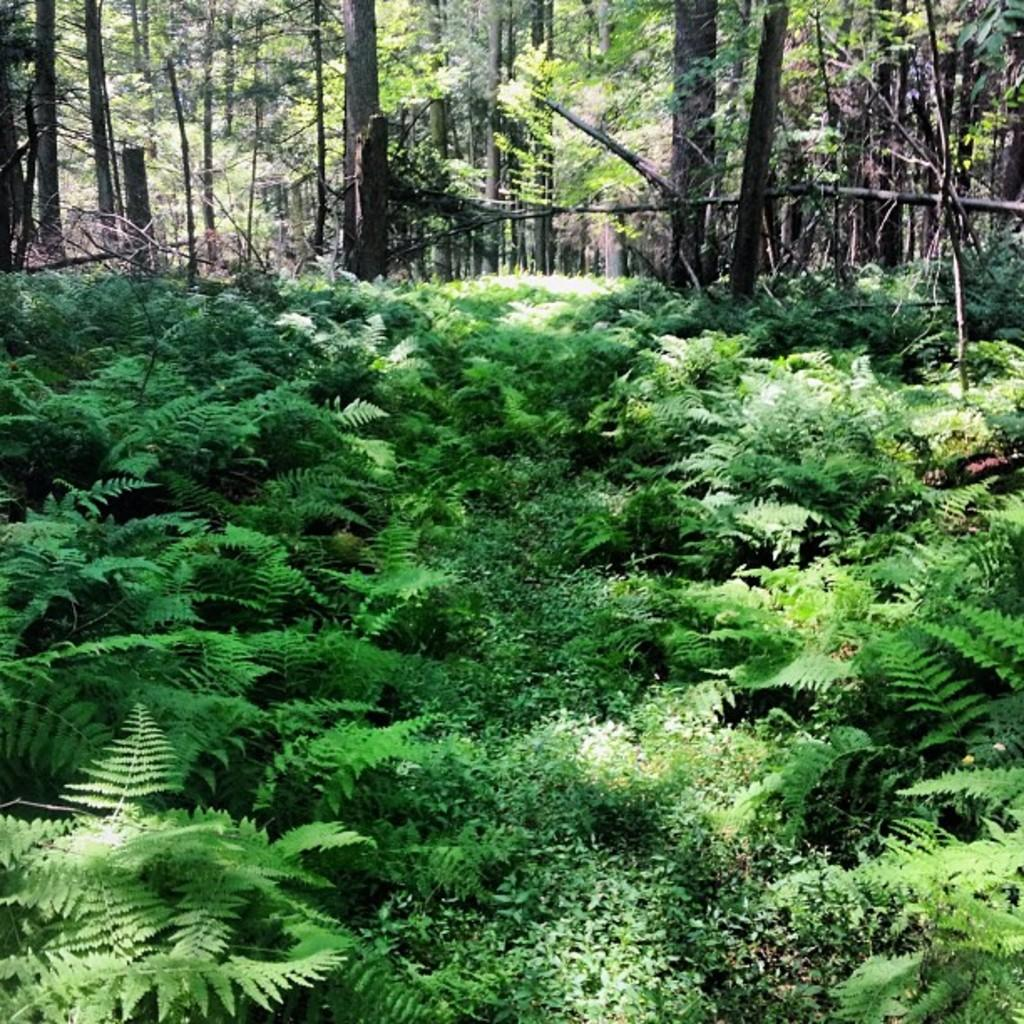What type of living organisms can be seen in the image? Plants can be seen in the image. What color are the plants in the image? The plants are green in color. What can be seen in the background of the image? There are trees and wooden logs in the background of the image. What is the color of the wooden logs in the image? The wooden logs are brown in color. What type of spark can be seen coming from the plants in the image? There is no spark present in the image; the plants are not emitting any sparks. 